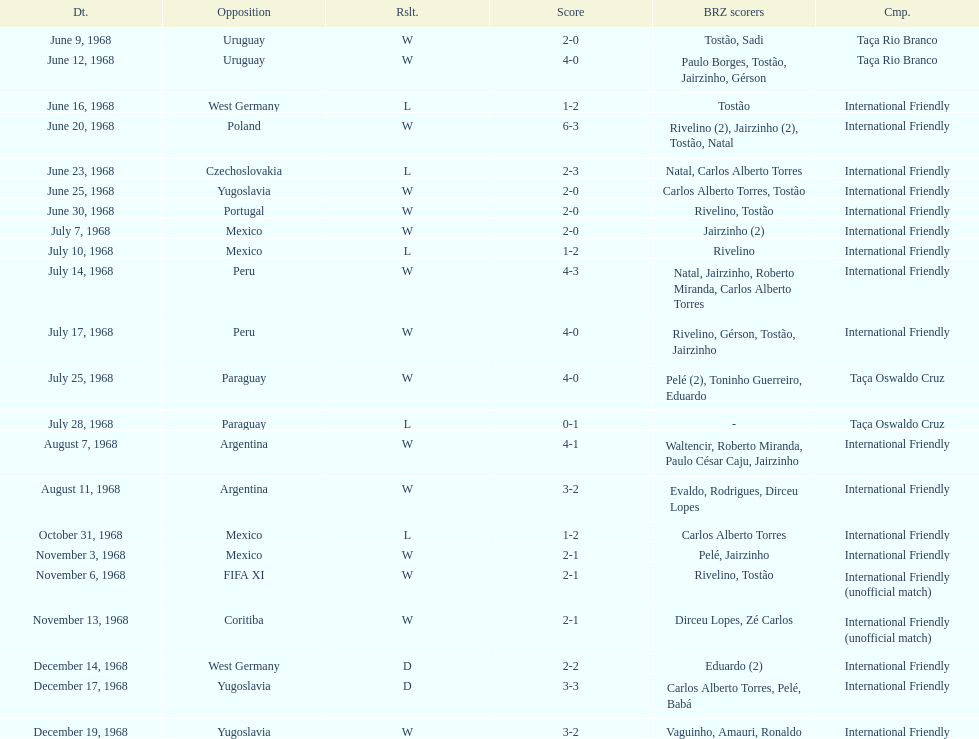Would you mind parsing the complete table? {'header': ['Dt.', 'Opposition', 'Rslt.', 'Score', 'BRZ scorers', 'Cmp.'], 'rows': [['June 9, 1968', 'Uruguay', 'W', '2-0', 'Tostão, Sadi', 'Taça Rio Branco'], ['June 12, 1968', 'Uruguay', 'W', '4-0', 'Paulo Borges, Tostão, Jairzinho, Gérson', 'Taça Rio Branco'], ['June 16, 1968', 'West Germany', 'L', '1-2', 'Tostão', 'International Friendly'], ['June 20, 1968', 'Poland', 'W', '6-3', 'Rivelino (2), Jairzinho (2), Tostão, Natal', 'International Friendly'], ['June 23, 1968', 'Czechoslovakia', 'L', '2-3', 'Natal, Carlos Alberto Torres', 'International Friendly'], ['June 25, 1968', 'Yugoslavia', 'W', '2-0', 'Carlos Alberto Torres, Tostão', 'International Friendly'], ['June 30, 1968', 'Portugal', 'W', '2-0', 'Rivelino, Tostão', 'International Friendly'], ['July 7, 1968', 'Mexico', 'W', '2-0', 'Jairzinho (2)', 'International Friendly'], ['July 10, 1968', 'Mexico', 'L', '1-2', 'Rivelino', 'International Friendly'], ['July 14, 1968', 'Peru', 'W', '4-3', 'Natal, Jairzinho, Roberto Miranda, Carlos Alberto Torres', 'International Friendly'], ['July 17, 1968', 'Peru', 'W', '4-0', 'Rivelino, Gérson, Tostão, Jairzinho', 'International Friendly'], ['July 25, 1968', 'Paraguay', 'W', '4-0', 'Pelé (2), Toninho Guerreiro, Eduardo', 'Taça Oswaldo Cruz'], ['July 28, 1968', 'Paraguay', 'L', '0-1', '-', 'Taça Oswaldo Cruz'], ['August 7, 1968', 'Argentina', 'W', '4-1', 'Waltencir, Roberto Miranda, Paulo César Caju, Jairzinho', 'International Friendly'], ['August 11, 1968', 'Argentina', 'W', '3-2', 'Evaldo, Rodrigues, Dirceu Lopes', 'International Friendly'], ['October 31, 1968', 'Mexico', 'L', '1-2', 'Carlos Alberto Torres', 'International Friendly'], ['November 3, 1968', 'Mexico', 'W', '2-1', 'Pelé, Jairzinho', 'International Friendly'], ['November 6, 1968', 'FIFA XI', 'W', '2-1', 'Rivelino, Tostão', 'International Friendly (unofficial match)'], ['November 13, 1968', 'Coritiba', 'W', '2-1', 'Dirceu Lopes, Zé Carlos', 'International Friendly (unofficial match)'], ['December 14, 1968', 'West Germany', 'D', '2-2', 'Eduardo (2)', 'International Friendly'], ['December 17, 1968', 'Yugoslavia', 'D', '3-3', 'Carlos Alberto Torres, Pelé, Babá', 'International Friendly'], ['December 19, 1968', 'Yugoslavia', 'W', '3-2', 'Vaguinho, Amauri, Ronaldo', 'International Friendly']]} What is the number of countries they have played? 11. 